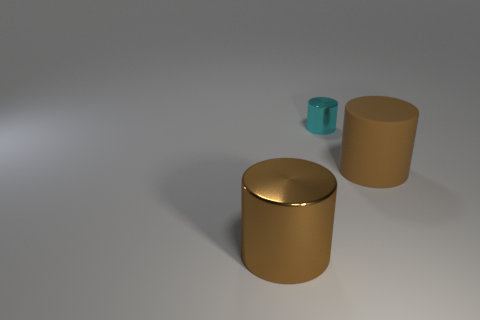Subtract 1 cylinders. How many cylinders are left? 2 Subtract all metal cylinders. How many cylinders are left? 1 Add 2 big red rubber cylinders. How many objects exist? 5 Add 2 big metallic cylinders. How many big metallic cylinders are left? 3 Add 2 big cylinders. How many big cylinders exist? 4 Subtract 0 red spheres. How many objects are left? 3 Subtract all tiny cyan shiny cylinders. Subtract all tiny shiny cylinders. How many objects are left? 1 